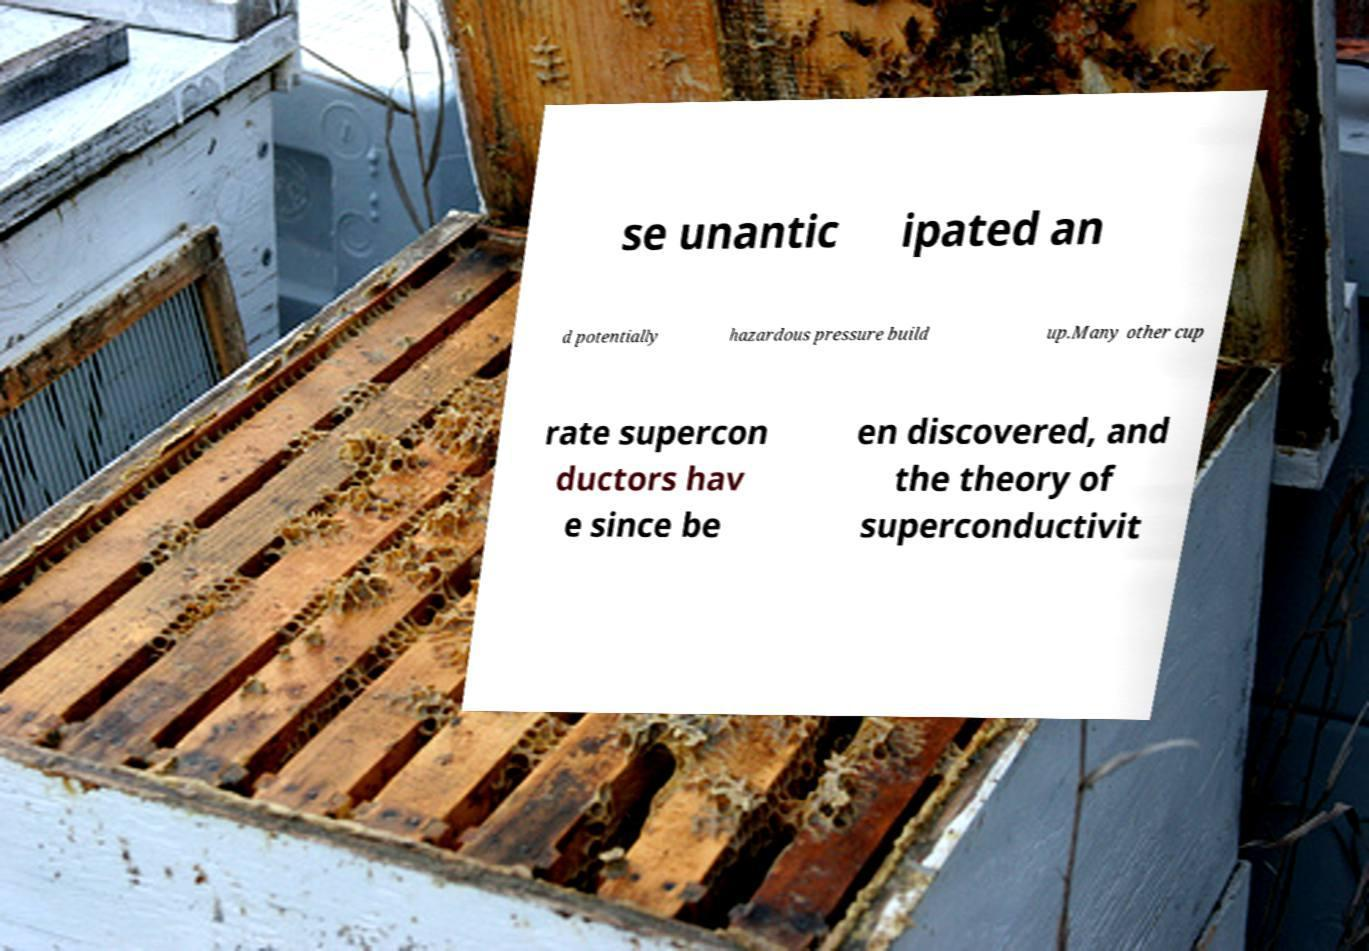Could you assist in decoding the text presented in this image and type it out clearly? se unantic ipated an d potentially hazardous pressure build up.Many other cup rate supercon ductors hav e since be en discovered, and the theory of superconductivit 